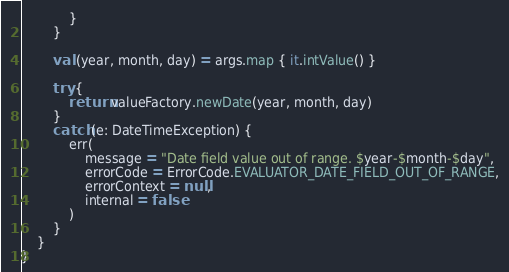<code> <loc_0><loc_0><loc_500><loc_500><_Kotlin_>            }
        }

        val (year, month, day) = args.map { it.intValue() }

        try {
            return valueFactory.newDate(year, month, day)
        }
        catch (e: DateTimeException) {
            err(
                message = "Date field value out of range. $year-$month-$day",
                errorCode = ErrorCode.EVALUATOR_DATE_FIELD_OUT_OF_RANGE,
                errorContext = null,
                internal = false
            )
        }
    }
}</code> 